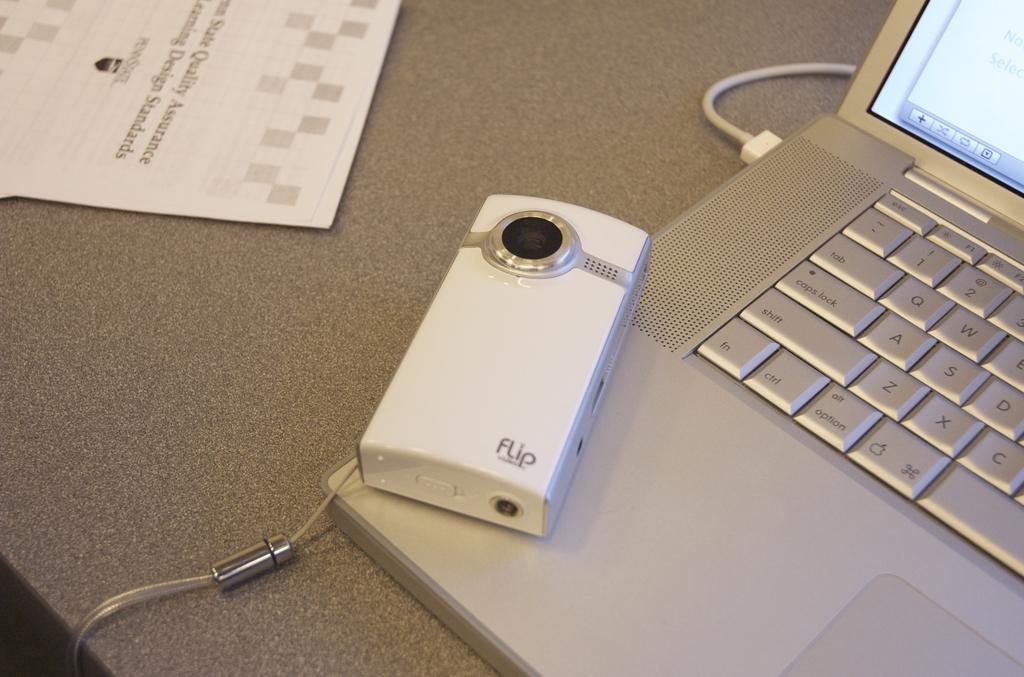What is the name of the equipment shown?
Offer a terse response. Flip. What is the name of the camera printed on its front?
Provide a succinct answer. Flip. 